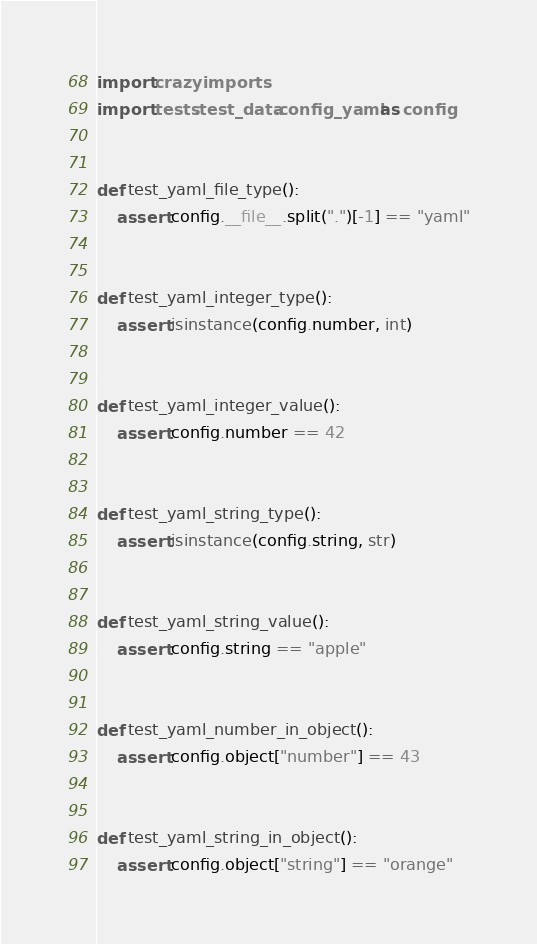<code> <loc_0><loc_0><loc_500><loc_500><_Python_>import crazyimports
import tests.test_data.config_yaml as config


def test_yaml_file_type():
    assert config.__file__.split(".")[-1] == "yaml"


def test_yaml_integer_type():
    assert isinstance(config.number, int)


def test_yaml_integer_value():
    assert config.number == 42


def test_yaml_string_type():
    assert isinstance(config.string, str)


def test_yaml_string_value():
    assert config.string == "apple"


def test_yaml_number_in_object():
    assert config.object["number"] == 43


def test_yaml_string_in_object():
    assert config.object["string"] == "orange"
</code> 